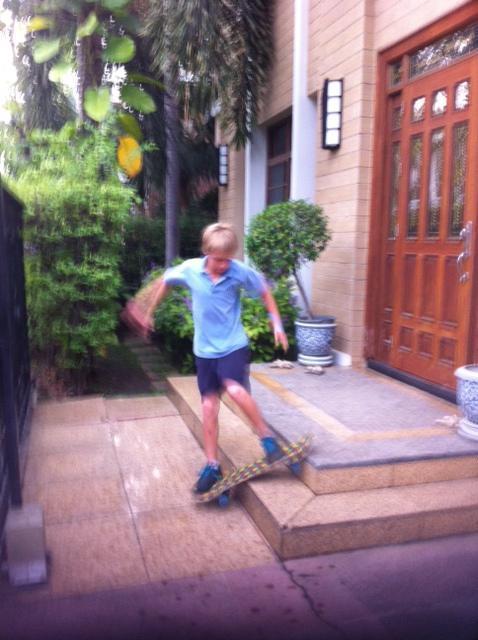How many steps lead to the door?
Give a very brief answer. 2. 